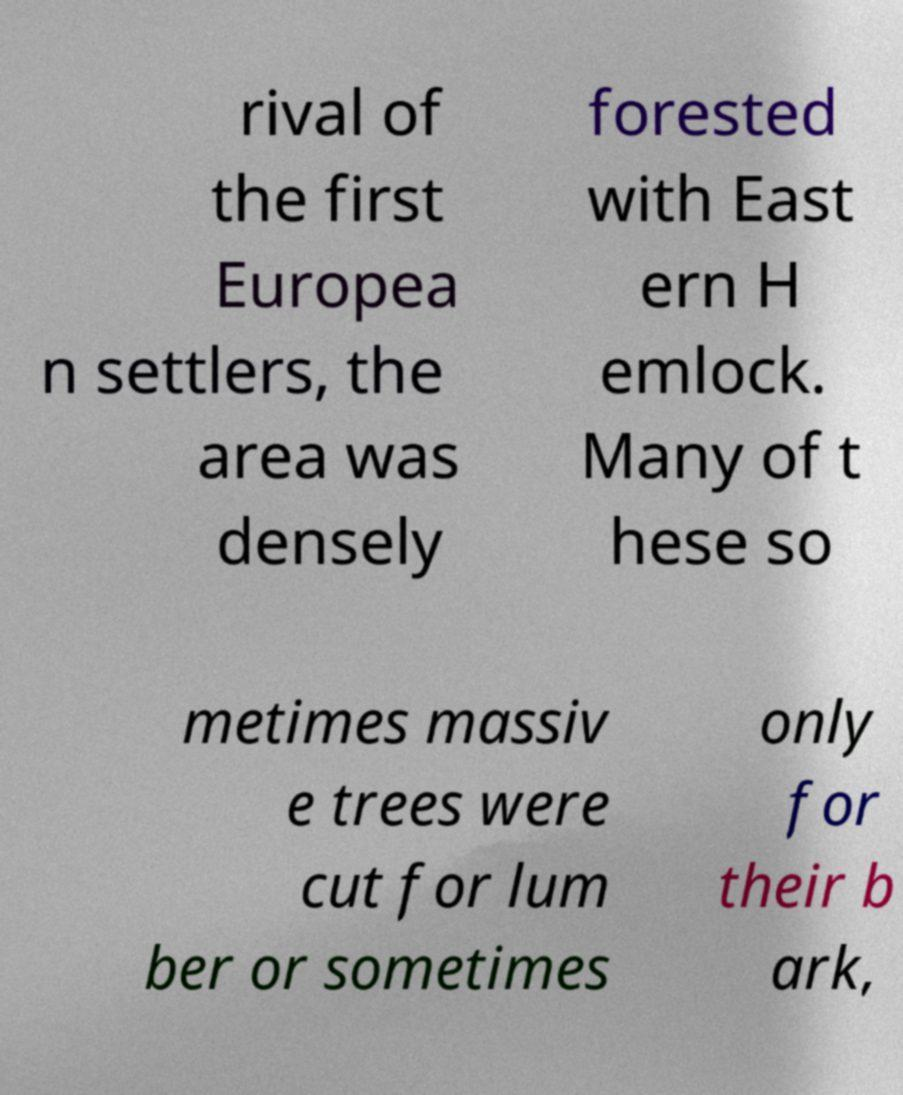For documentation purposes, I need the text within this image transcribed. Could you provide that? rival of the first Europea n settlers, the area was densely forested with East ern H emlock. Many of t hese so metimes massiv e trees were cut for lum ber or sometimes only for their b ark, 